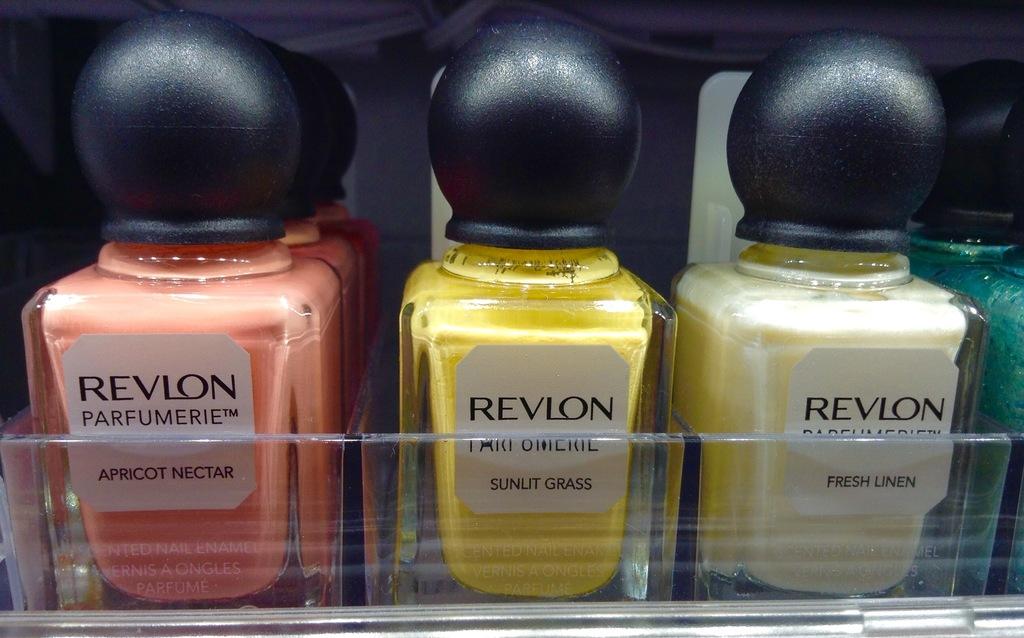What is the brand of the bottles?
Keep it short and to the point. Revlon. What color on far left?
Ensure brevity in your answer.  Apricot nectar. 